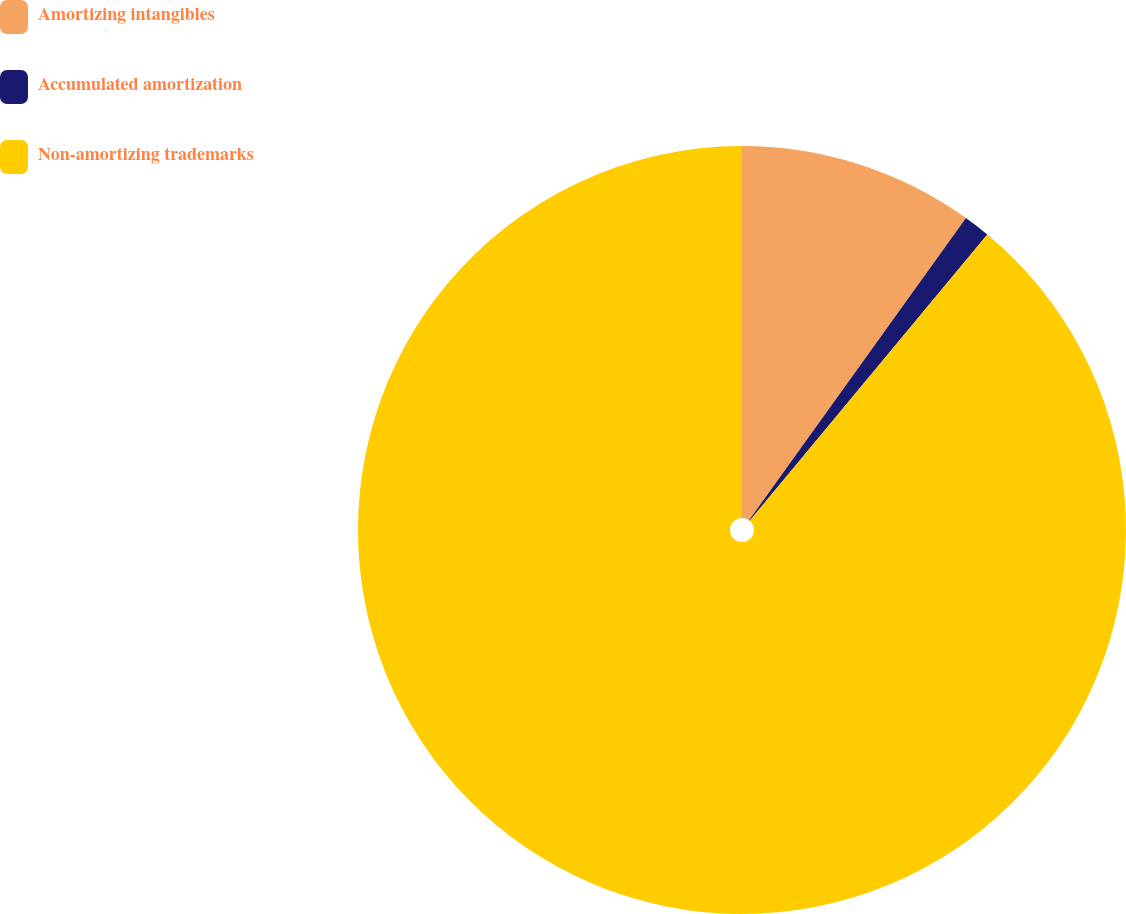Convert chart to OTSL. <chart><loc_0><loc_0><loc_500><loc_500><pie_chart><fcel>Amortizing intangibles<fcel>Accumulated amortization<fcel>Non-amortizing trademarks<nl><fcel>9.91%<fcel>1.12%<fcel>88.97%<nl></chart> 